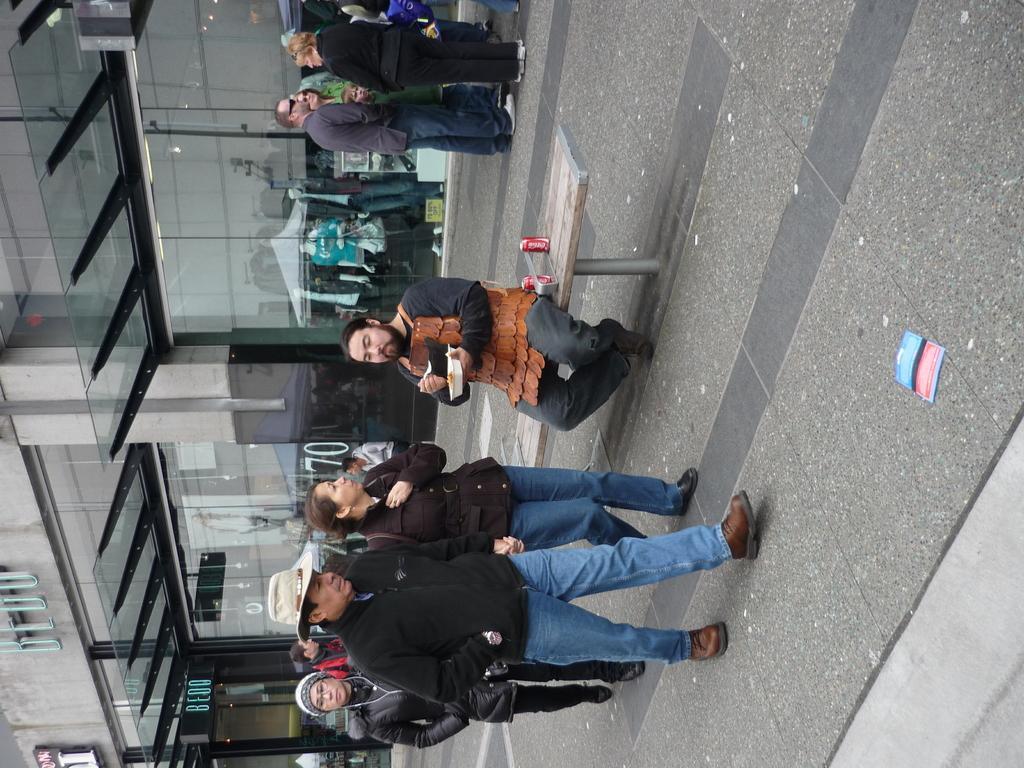Can you describe this image briefly? This picture describes about group of people, few are walking and few are standing, in the middle of the image we can see a man, he is seated on the bench, beside to him we can find few times, and he is holding a plate, in the background we can find few buildings and mannequins. 